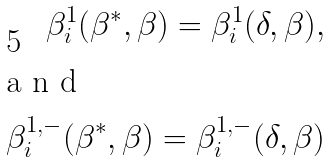<formula> <loc_0><loc_0><loc_500><loc_500>\beta ^ { 1 } _ { i } ( \beta ^ { * } , \beta ) = \beta ^ { 1 } _ { i } ( \delta , \beta ) , \\ \intertext { a n d } \beta ^ { 1 , - } _ { i } ( \beta ^ { * } , \beta ) = \beta ^ { 1 , - } _ { i } ( \delta , \beta )</formula> 